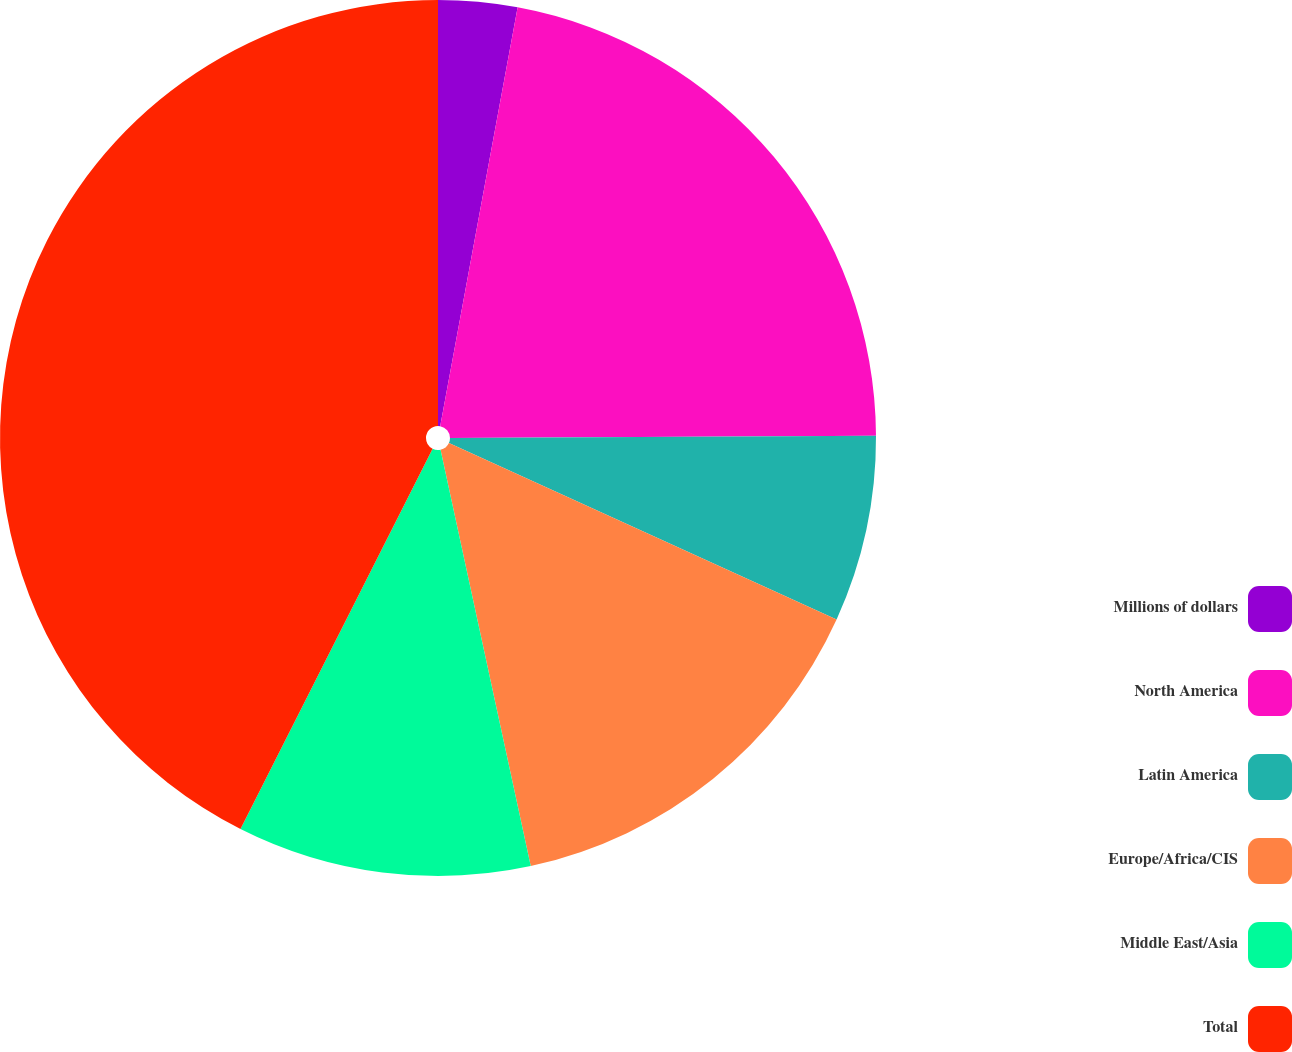Convert chart to OTSL. <chart><loc_0><loc_0><loc_500><loc_500><pie_chart><fcel>Millions of dollars<fcel>North America<fcel>Latin America<fcel>Europe/Africa/CIS<fcel>Middle East/Asia<fcel>Total<nl><fcel>2.91%<fcel>22.01%<fcel>6.88%<fcel>14.8%<fcel>10.84%<fcel>42.55%<nl></chart> 